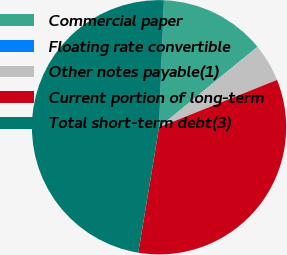Convert chart. <chart><loc_0><loc_0><loc_500><loc_500><pie_chart><fcel>Commercial paper<fcel>Floating rate convertible<fcel>Other notes payable(1)<fcel>Current portion of long-term<fcel>Total short-term debt(3)<nl><fcel>13.46%<fcel>0.03%<fcel>4.83%<fcel>33.69%<fcel>47.99%<nl></chart> 